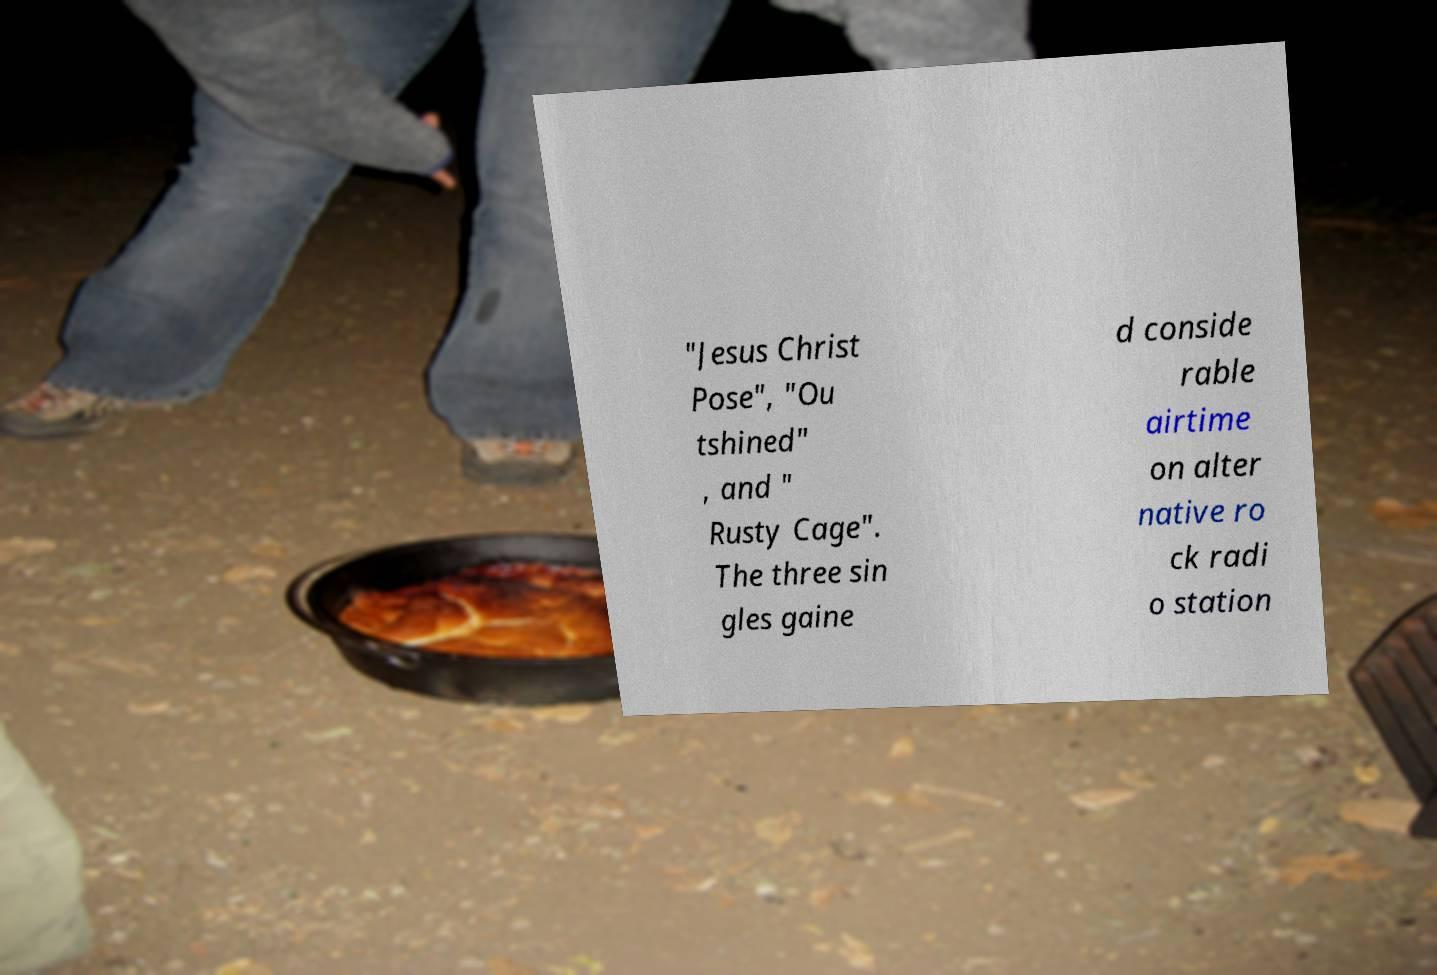I need the written content from this picture converted into text. Can you do that? "Jesus Christ Pose", "Ou tshined" , and " Rusty Cage". The three sin gles gaine d conside rable airtime on alter native ro ck radi o station 